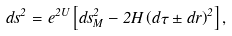<formula> <loc_0><loc_0><loc_500><loc_500>d s ^ { 2 } = e ^ { 2 U } \left [ d s ^ { 2 } _ { M } - 2 H \left ( d \tau \pm d r \right ) ^ { 2 } \right ] ,</formula> 